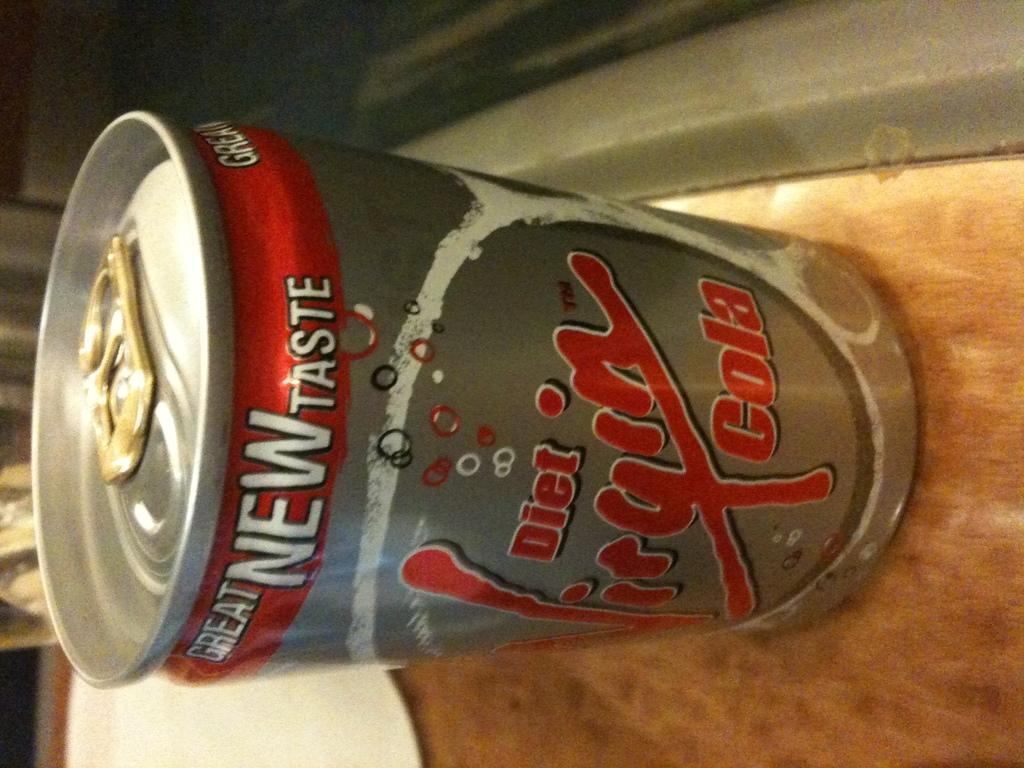<image>
Write a terse but informative summary of the picture. A diet cola that has a great new taste 